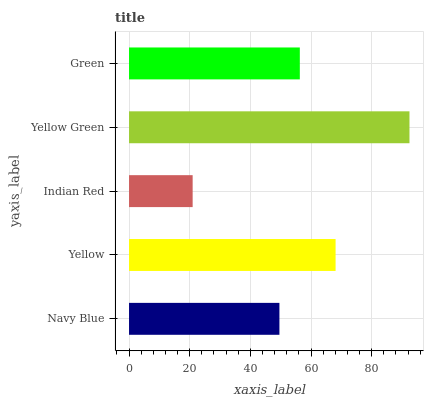Is Indian Red the minimum?
Answer yes or no. Yes. Is Yellow Green the maximum?
Answer yes or no. Yes. Is Yellow the minimum?
Answer yes or no. No. Is Yellow the maximum?
Answer yes or no. No. Is Yellow greater than Navy Blue?
Answer yes or no. Yes. Is Navy Blue less than Yellow?
Answer yes or no. Yes. Is Navy Blue greater than Yellow?
Answer yes or no. No. Is Yellow less than Navy Blue?
Answer yes or no. No. Is Green the high median?
Answer yes or no. Yes. Is Green the low median?
Answer yes or no. Yes. Is Yellow Green the high median?
Answer yes or no. No. Is Navy Blue the low median?
Answer yes or no. No. 